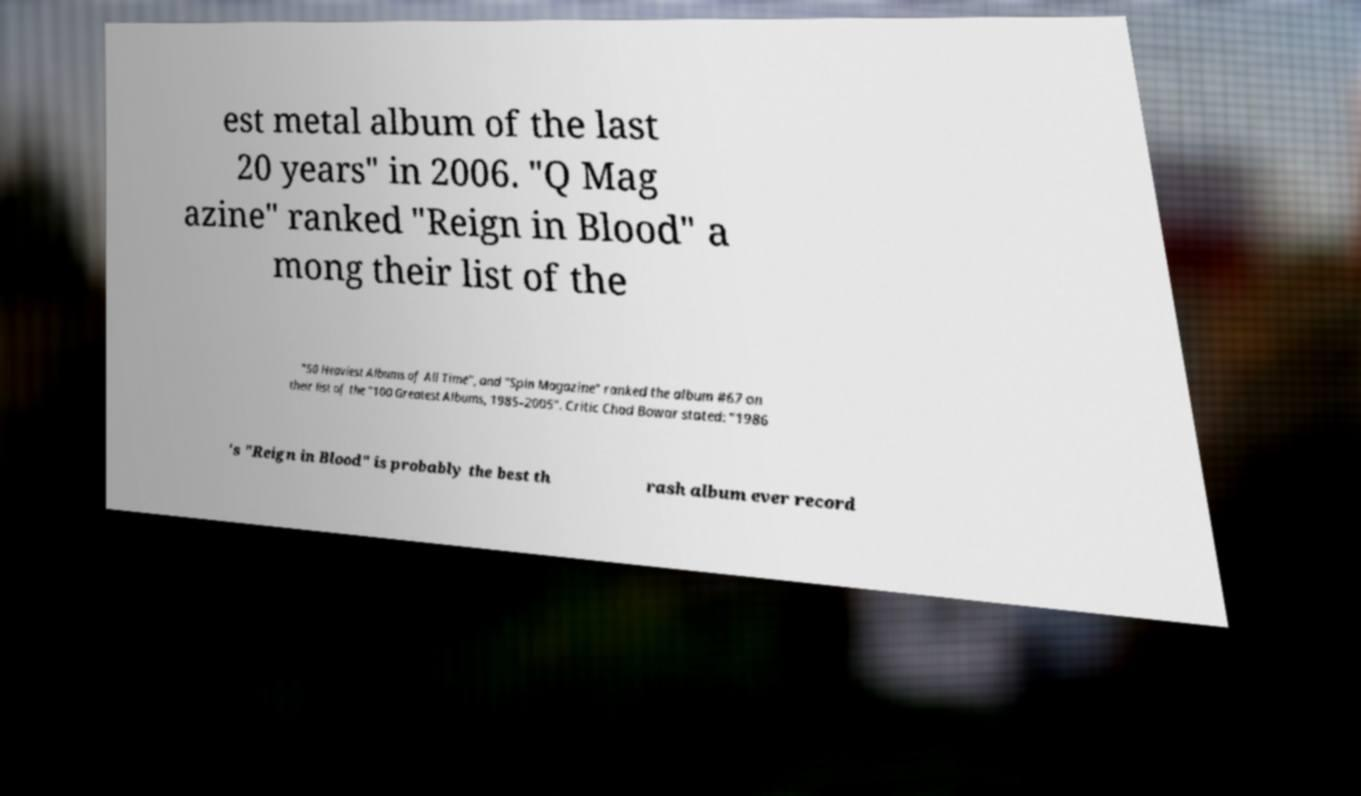Please identify and transcribe the text found in this image. est metal album of the last 20 years" in 2006. "Q Mag azine" ranked "Reign in Blood" a mong their list of the "50 Heaviest Albums of All Time", and "Spin Magazine" ranked the album #67 on their list of the "100 Greatest Albums, 1985–2005". Critic Chad Bowar stated: "1986 's "Reign in Blood" is probably the best th rash album ever record 